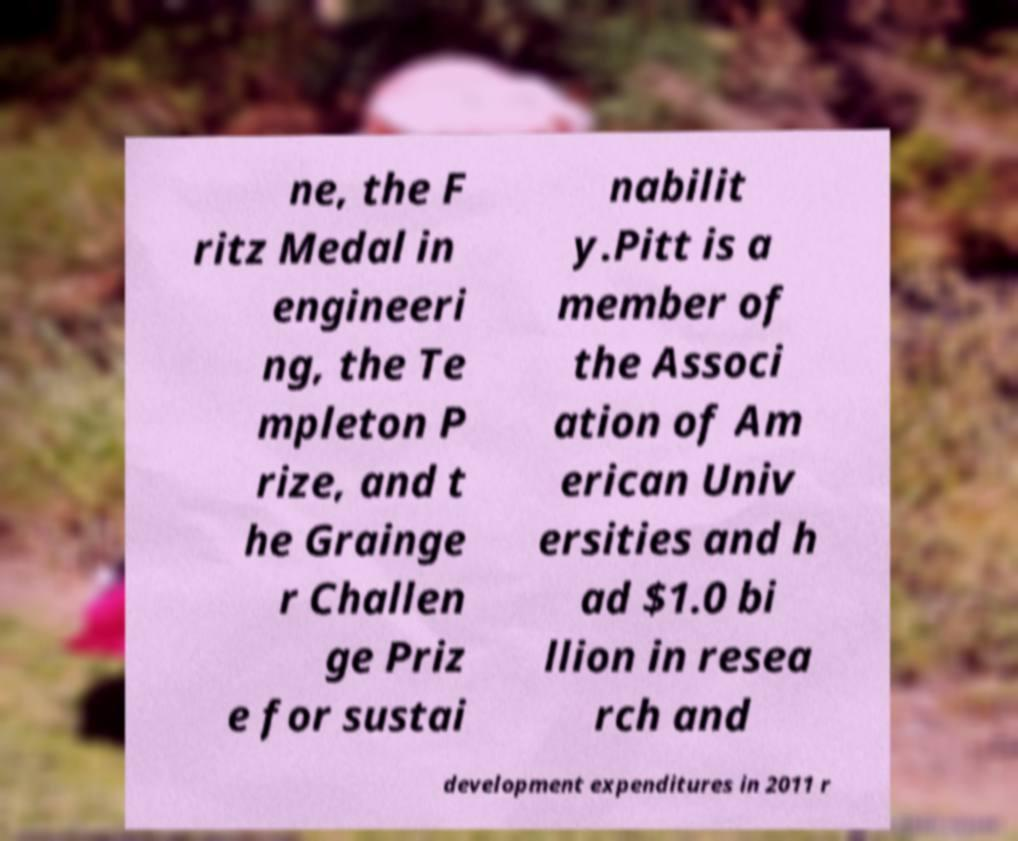What messages or text are displayed in this image? I need them in a readable, typed format. ne, the F ritz Medal in engineeri ng, the Te mpleton P rize, and t he Grainge r Challen ge Priz e for sustai nabilit y.Pitt is a member of the Associ ation of Am erican Univ ersities and h ad $1.0 bi llion in resea rch and development expenditures in 2011 r 